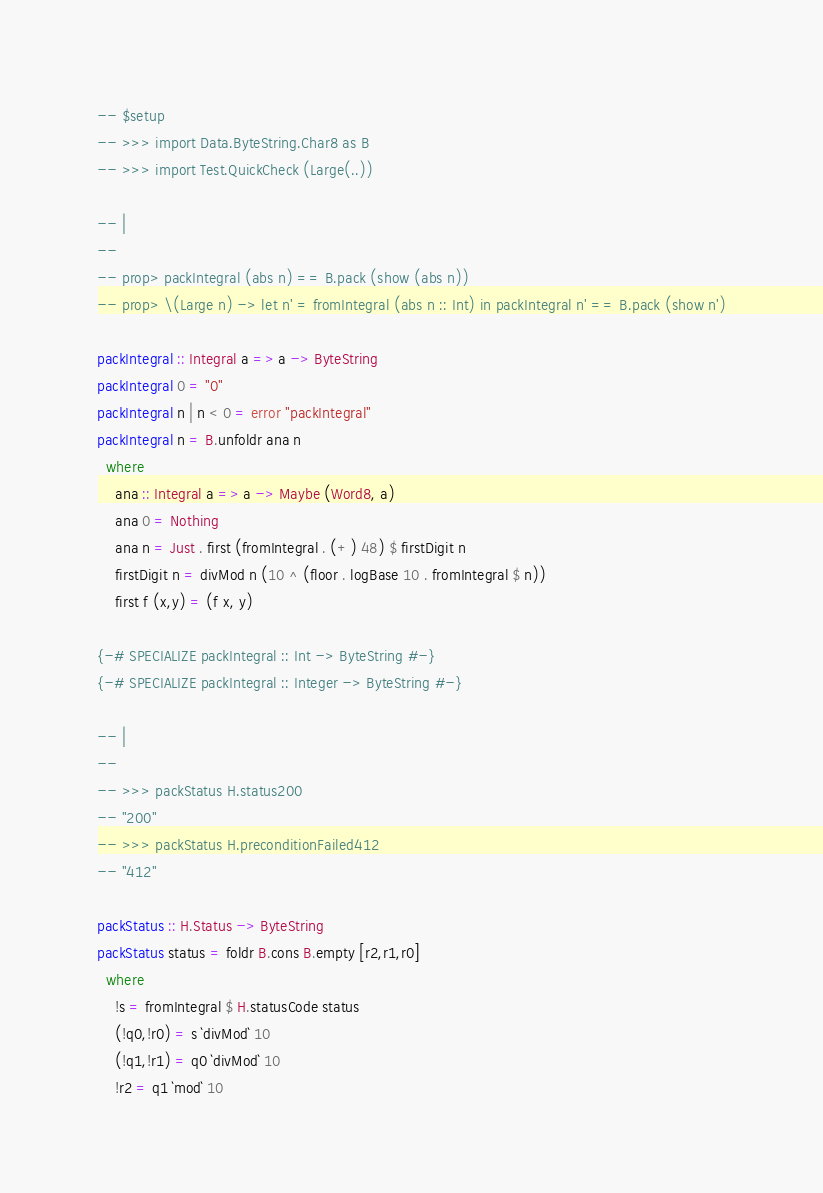<code> <loc_0><loc_0><loc_500><loc_500><_Haskell_>

-- $setup
-- >>> import Data.ByteString.Char8 as B
-- >>> import Test.QuickCheck (Large(..))

-- |
--
-- prop> packIntegral (abs n) == B.pack (show (abs n))
-- prop> \(Large n) -> let n' = fromIntegral (abs n :: Int) in packIntegral n' == B.pack (show n')

packIntegral :: Integral a => a -> ByteString
packIntegral 0 = "0"
packIntegral n | n < 0 = error "packIntegral"
packIntegral n = B.unfoldr ana n
  where
    ana :: Integral a => a -> Maybe (Word8, a)
    ana 0 = Nothing
    ana n = Just . first (fromIntegral . (+) 48) $ firstDigit n
    firstDigit n = divMod n (10 ^ (floor . logBase 10 . fromIntegral $ n))
    first f (x,y) = (f x, y)

{-# SPECIALIZE packIntegral :: Int -> ByteString #-}
{-# SPECIALIZE packIntegral :: Integer -> ByteString #-}

-- |
--
-- >>> packStatus H.status200
-- "200"
-- >>> packStatus H.preconditionFailed412
-- "412"

packStatus :: H.Status -> ByteString
packStatus status = foldr B.cons B.empty [r2,r1,r0]
  where
    !s = fromIntegral $ H.statusCode status
    (!q0,!r0) = s `divMod` 10
    (!q1,!r1) = q0 `divMod` 10
    !r2 = q1 `mod` 10
</code> 